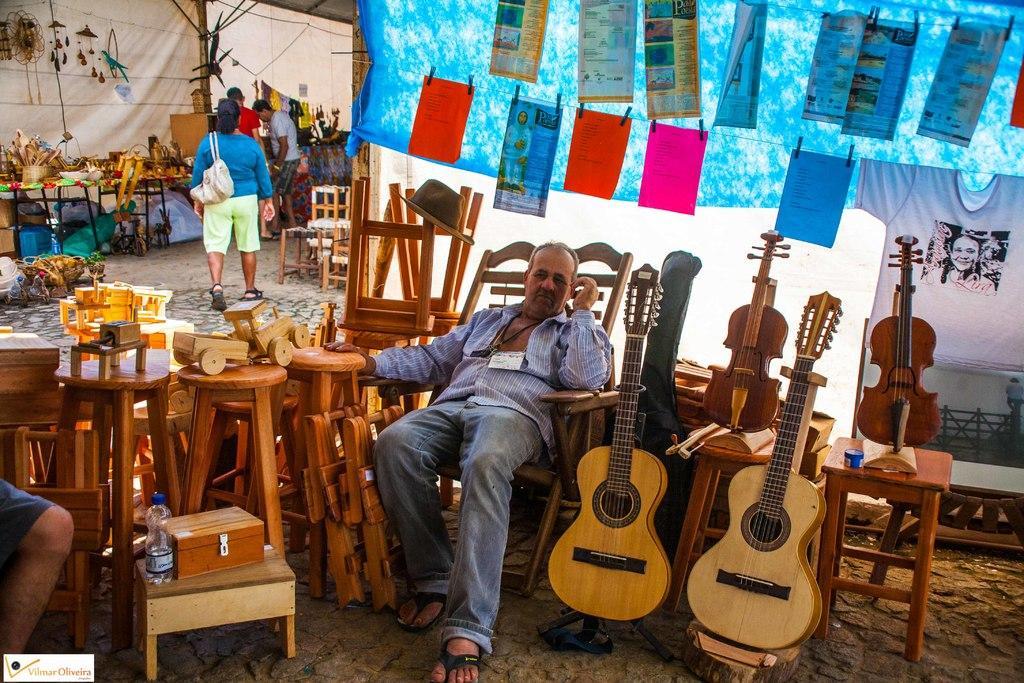Describe this image in one or two sentences. In this image,, few peoples are there. We can see musical instruments on the right side. We can see there is a wooden things are placed on the left side and bottle. And the back side, we can see papers are hanging on the wire. Here few items are placed on the table. 